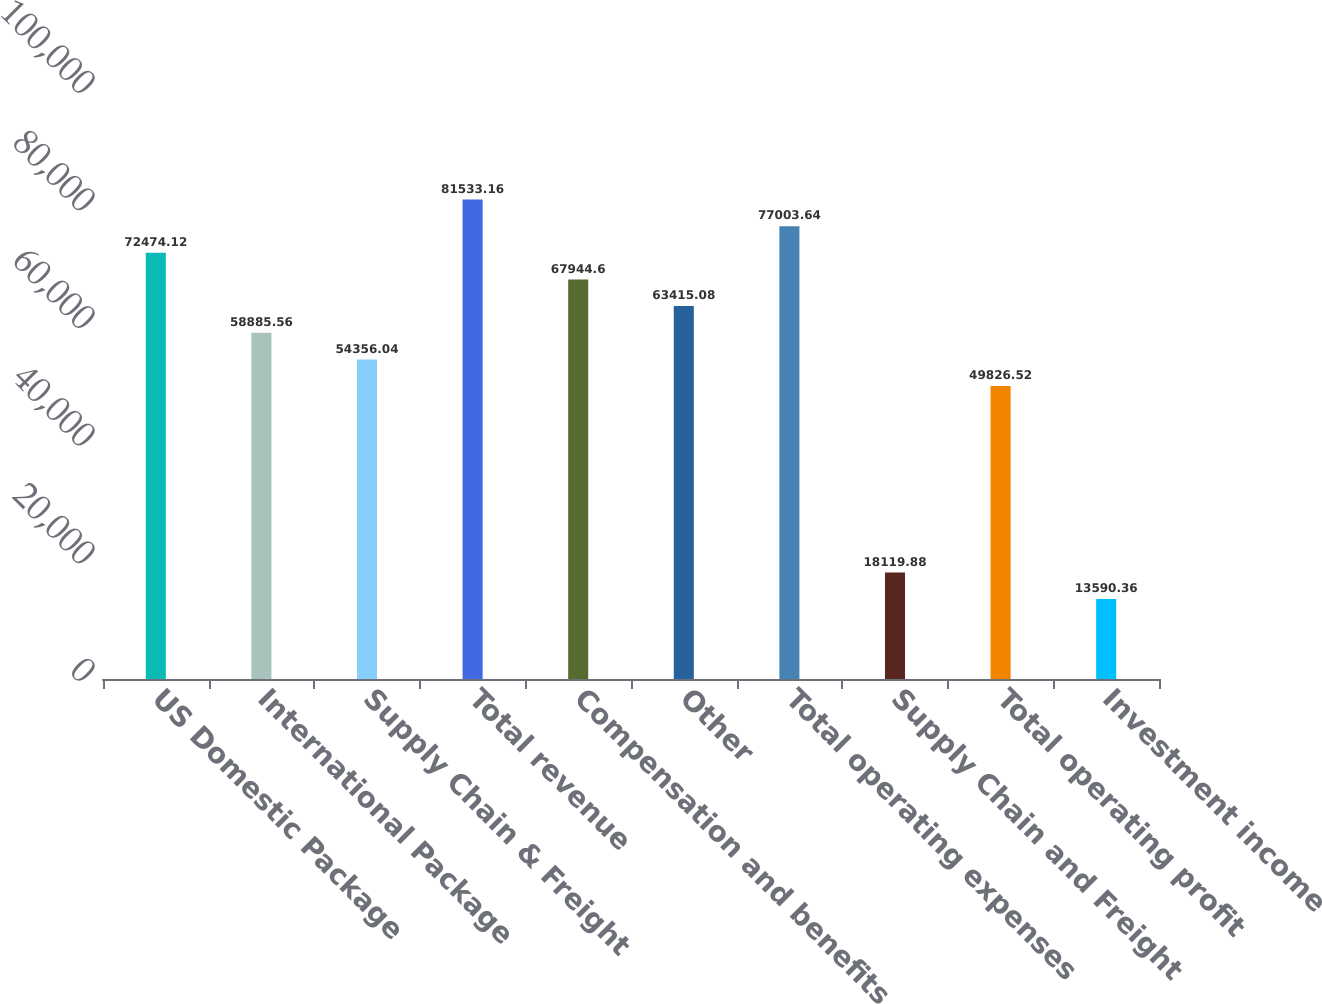Convert chart. <chart><loc_0><loc_0><loc_500><loc_500><bar_chart><fcel>US Domestic Package<fcel>International Package<fcel>Supply Chain & Freight<fcel>Total revenue<fcel>Compensation and benefits<fcel>Other<fcel>Total operating expenses<fcel>Supply Chain and Freight<fcel>Total operating profit<fcel>Investment income<nl><fcel>72474.1<fcel>58885.6<fcel>54356<fcel>81533.2<fcel>67944.6<fcel>63415.1<fcel>77003.6<fcel>18119.9<fcel>49826.5<fcel>13590.4<nl></chart> 